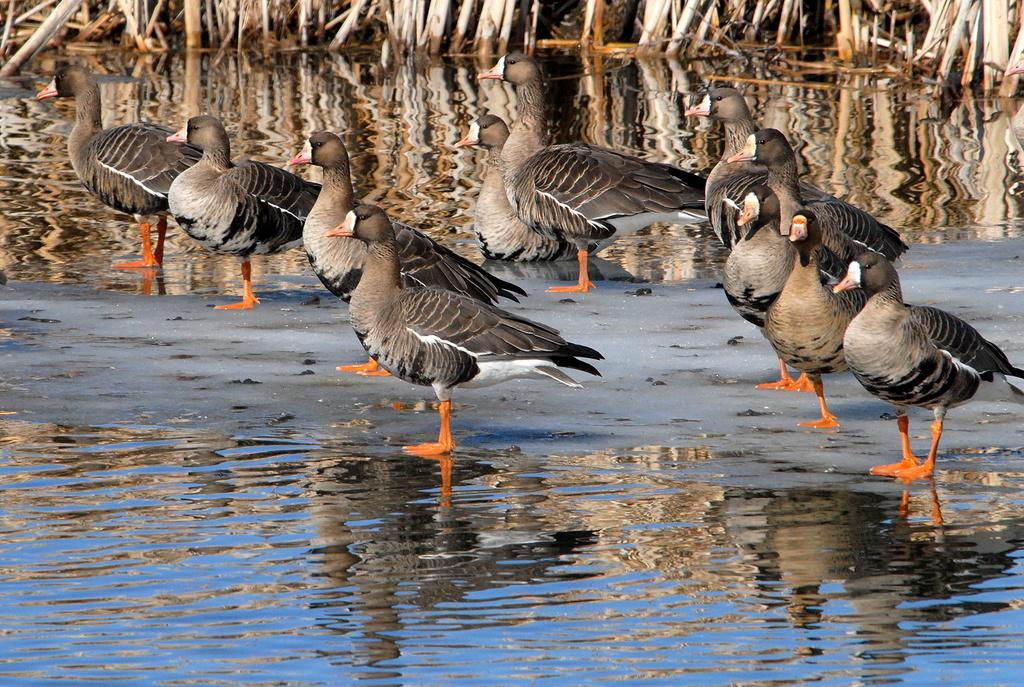What is at the bottom of the image? There is a water surface at the bottom of the image. What type of surface is behind the water surface? There is a sand surface behind the water surface. What animals can be seen on the sand surface? There are ducks on the sand surface. What can be seen in the background of the image? There is water visible in the background of the image, and there are sticks in the water. What sound can be heard coming from the ducks' noses in the image? There is no sound or indication of sound in the image, and ducks do not have noses. 